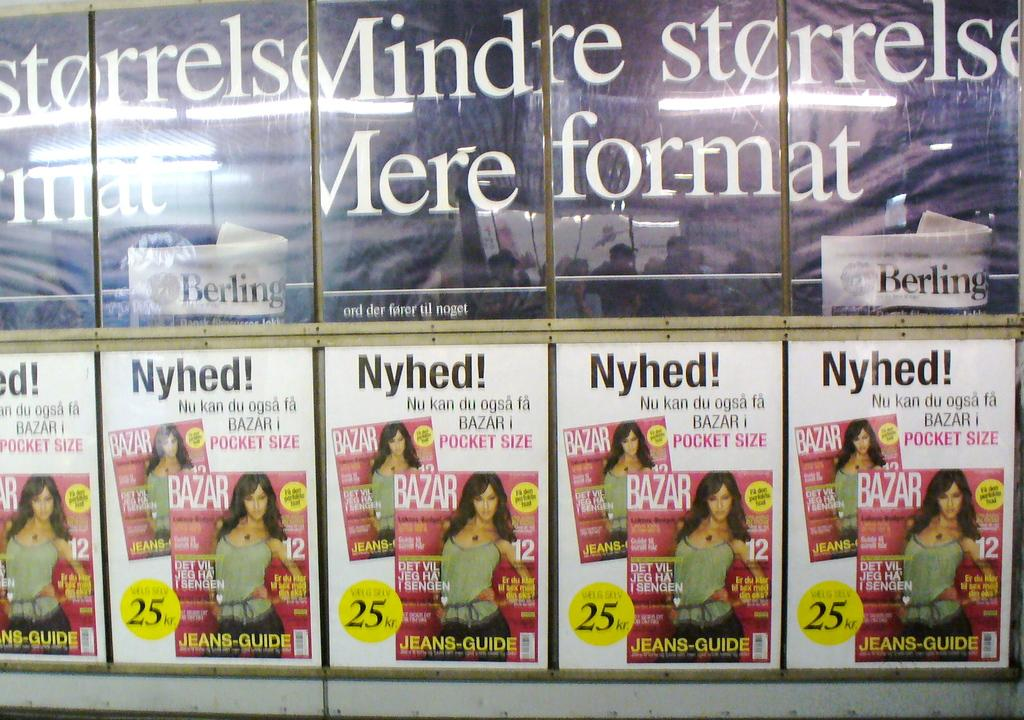<image>
Write a terse but informative summary of the picture. A row of flyers that have a woman on them and all say Nyhed. 